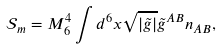<formula> <loc_0><loc_0><loc_500><loc_500>\mathcal { S } _ { m } = M _ { 6 } ^ { 4 } \int d ^ { 6 } x \sqrt { | \tilde { g } | } \tilde { g } ^ { A B } n _ { A B } ,</formula> 